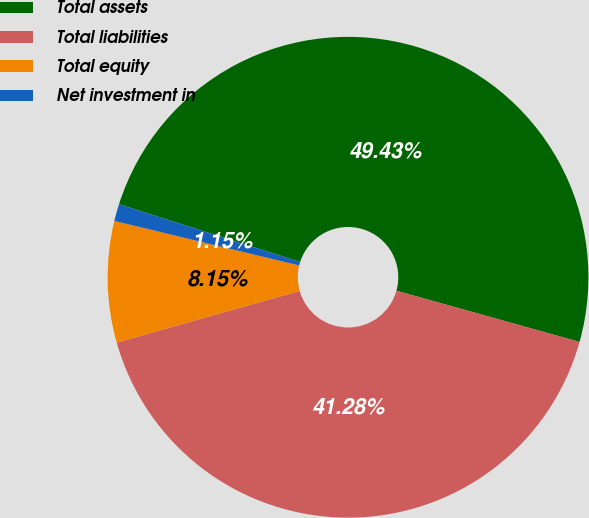<chart> <loc_0><loc_0><loc_500><loc_500><pie_chart><fcel>Total assets<fcel>Total liabilities<fcel>Total equity<fcel>Net investment in<nl><fcel>49.43%<fcel>41.28%<fcel>8.15%<fcel>1.15%<nl></chart> 